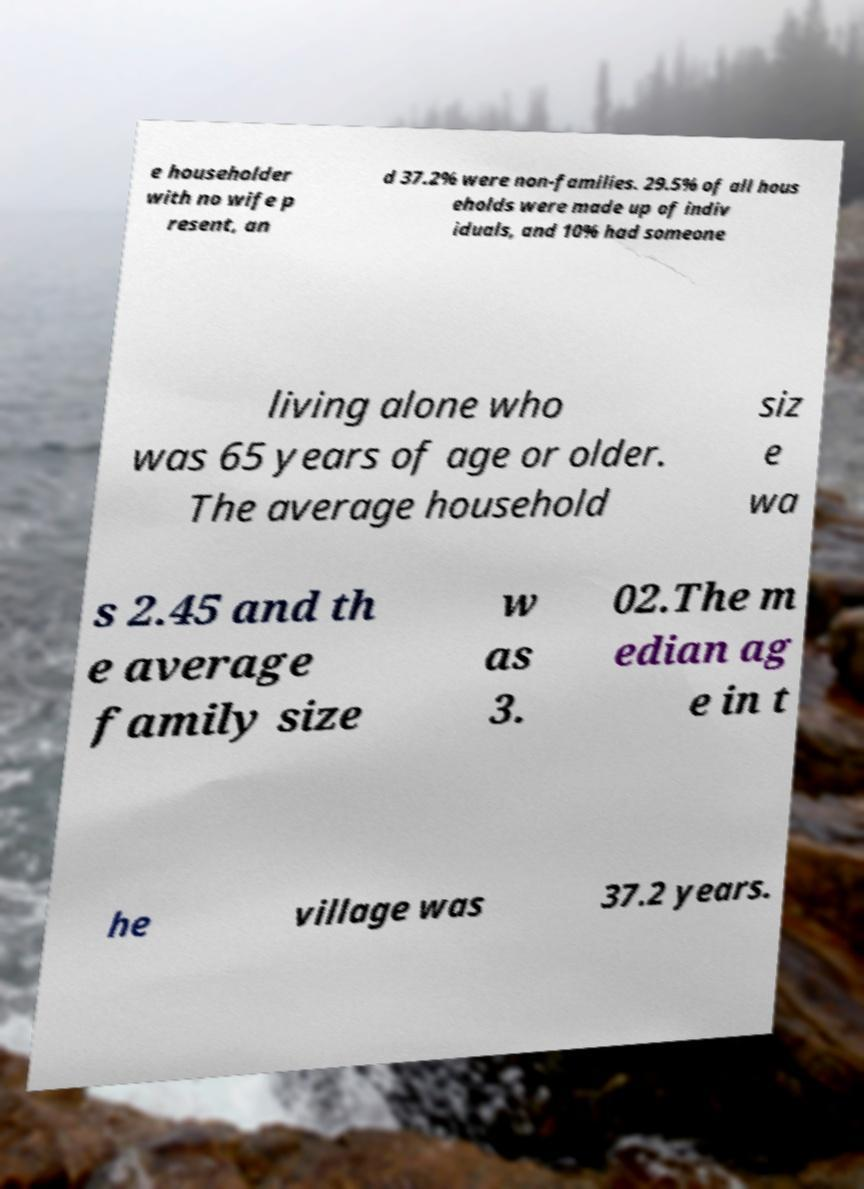For documentation purposes, I need the text within this image transcribed. Could you provide that? e householder with no wife p resent, an d 37.2% were non-families. 29.5% of all hous eholds were made up of indiv iduals, and 10% had someone living alone who was 65 years of age or older. The average household siz e wa s 2.45 and th e average family size w as 3. 02.The m edian ag e in t he village was 37.2 years. 